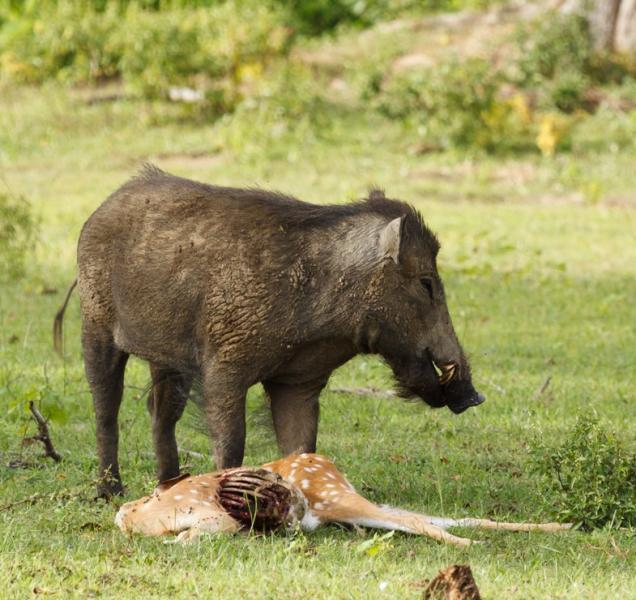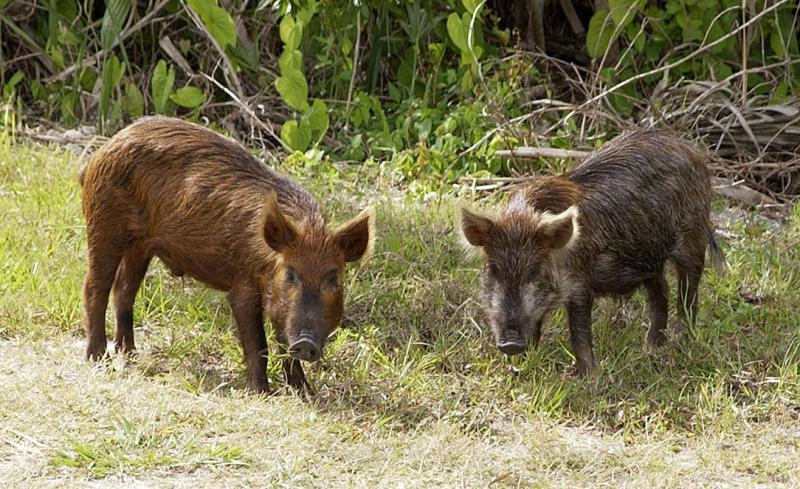The first image is the image on the left, the second image is the image on the right. Examine the images to the left and right. Is the description "In one of the image there is a tiger attacking a pig." accurate? Answer yes or no. No. The first image is the image on the left, the second image is the image on the right. For the images displayed, is the sentence "There is a tiger attacking a boar." factually correct? Answer yes or no. No. 